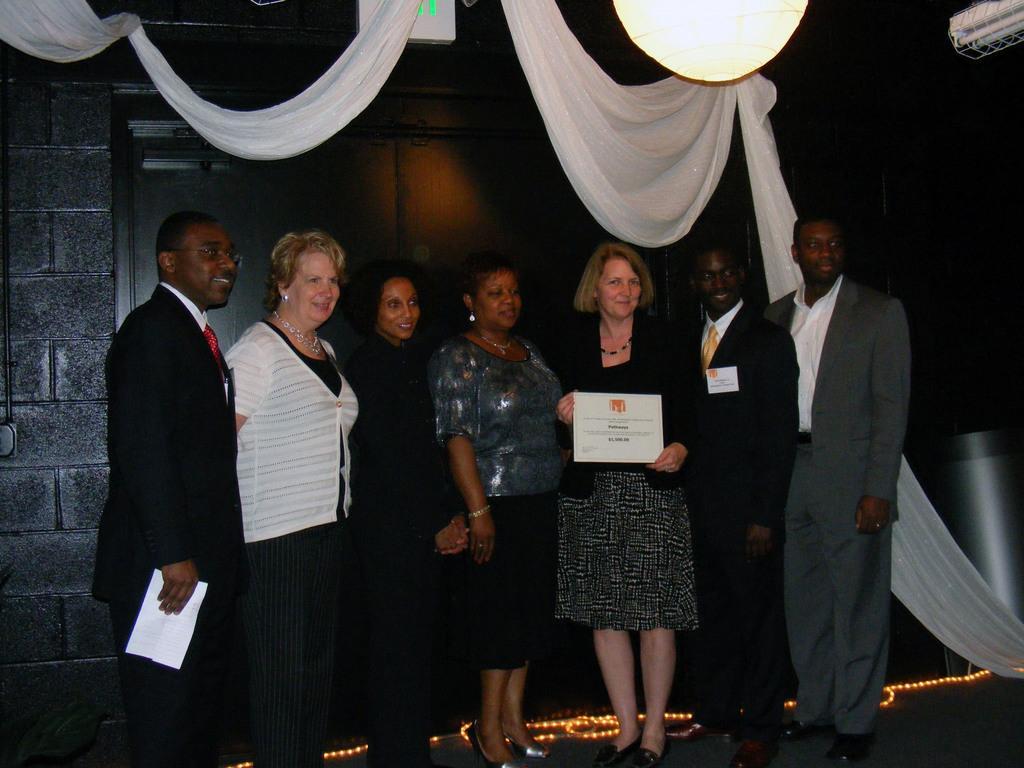Could you give a brief overview of what you see in this image? There are total of seven people. And this woman on the right side accepting some award. 